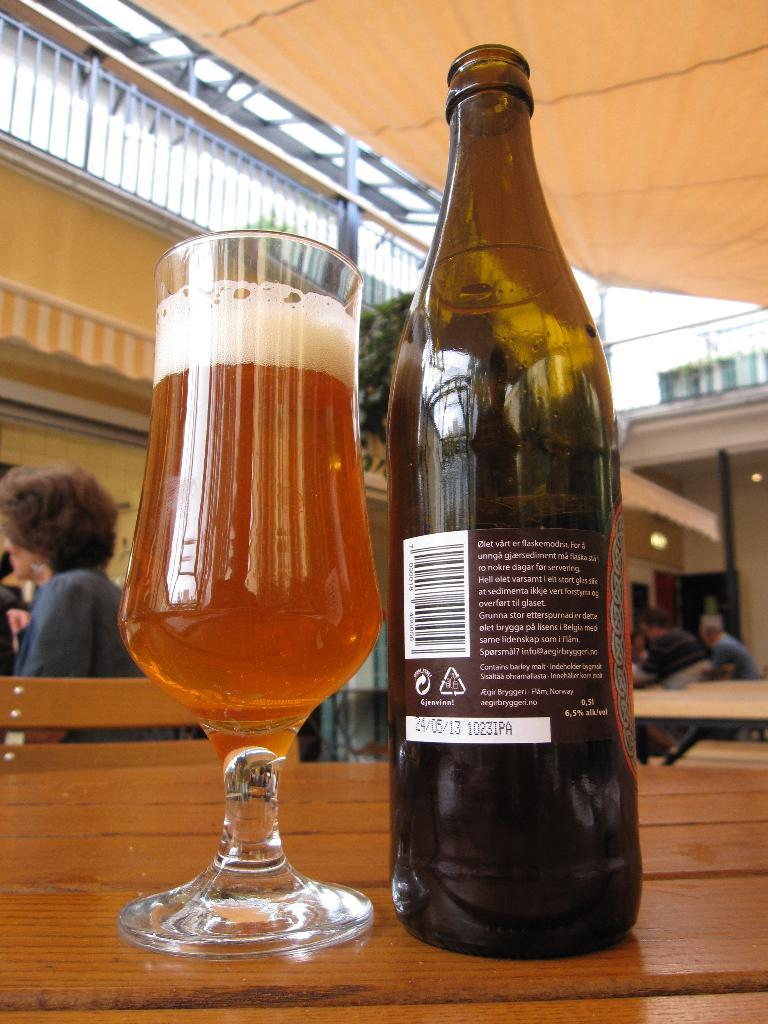<image>
Give a short and clear explanation of the subsequent image. A bottle of beer from Norway sits next to a full glass of beer. 